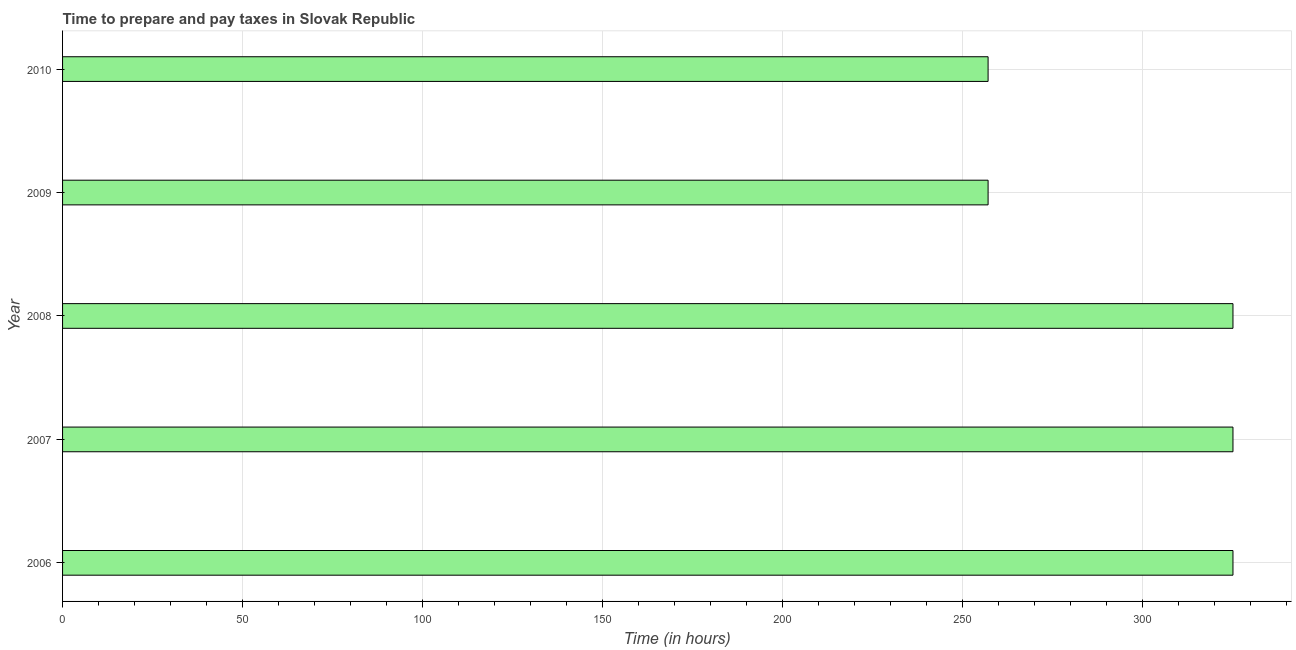Does the graph contain any zero values?
Provide a short and direct response. No. What is the title of the graph?
Provide a succinct answer. Time to prepare and pay taxes in Slovak Republic. What is the label or title of the X-axis?
Provide a succinct answer. Time (in hours). What is the label or title of the Y-axis?
Your answer should be very brief. Year. What is the time to prepare and pay taxes in 2006?
Ensure brevity in your answer.  325. Across all years, what is the maximum time to prepare and pay taxes?
Offer a very short reply. 325. Across all years, what is the minimum time to prepare and pay taxes?
Your response must be concise. 257. In which year was the time to prepare and pay taxes minimum?
Ensure brevity in your answer.  2009. What is the sum of the time to prepare and pay taxes?
Your response must be concise. 1489. What is the average time to prepare and pay taxes per year?
Provide a short and direct response. 297. What is the median time to prepare and pay taxes?
Give a very brief answer. 325. What is the ratio of the time to prepare and pay taxes in 2007 to that in 2010?
Provide a short and direct response. 1.26. What is the difference between the highest and the second highest time to prepare and pay taxes?
Offer a terse response. 0. In how many years, is the time to prepare and pay taxes greater than the average time to prepare and pay taxes taken over all years?
Ensure brevity in your answer.  3. Are all the bars in the graph horizontal?
Your response must be concise. Yes. What is the difference between two consecutive major ticks on the X-axis?
Your answer should be very brief. 50. What is the Time (in hours) of 2006?
Provide a succinct answer. 325. What is the Time (in hours) in 2007?
Offer a very short reply. 325. What is the Time (in hours) in 2008?
Your answer should be very brief. 325. What is the Time (in hours) of 2009?
Give a very brief answer. 257. What is the Time (in hours) in 2010?
Offer a terse response. 257. What is the difference between the Time (in hours) in 2006 and 2007?
Keep it short and to the point. 0. What is the difference between the Time (in hours) in 2006 and 2008?
Your answer should be compact. 0. What is the difference between the Time (in hours) in 2006 and 2010?
Offer a very short reply. 68. What is the difference between the Time (in hours) in 2007 and 2009?
Offer a terse response. 68. What is the difference between the Time (in hours) in 2008 and 2009?
Your response must be concise. 68. What is the ratio of the Time (in hours) in 2006 to that in 2009?
Make the answer very short. 1.26. What is the ratio of the Time (in hours) in 2006 to that in 2010?
Keep it short and to the point. 1.26. What is the ratio of the Time (in hours) in 2007 to that in 2009?
Your answer should be compact. 1.26. What is the ratio of the Time (in hours) in 2007 to that in 2010?
Make the answer very short. 1.26. What is the ratio of the Time (in hours) in 2008 to that in 2009?
Your answer should be very brief. 1.26. What is the ratio of the Time (in hours) in 2008 to that in 2010?
Your answer should be compact. 1.26. 